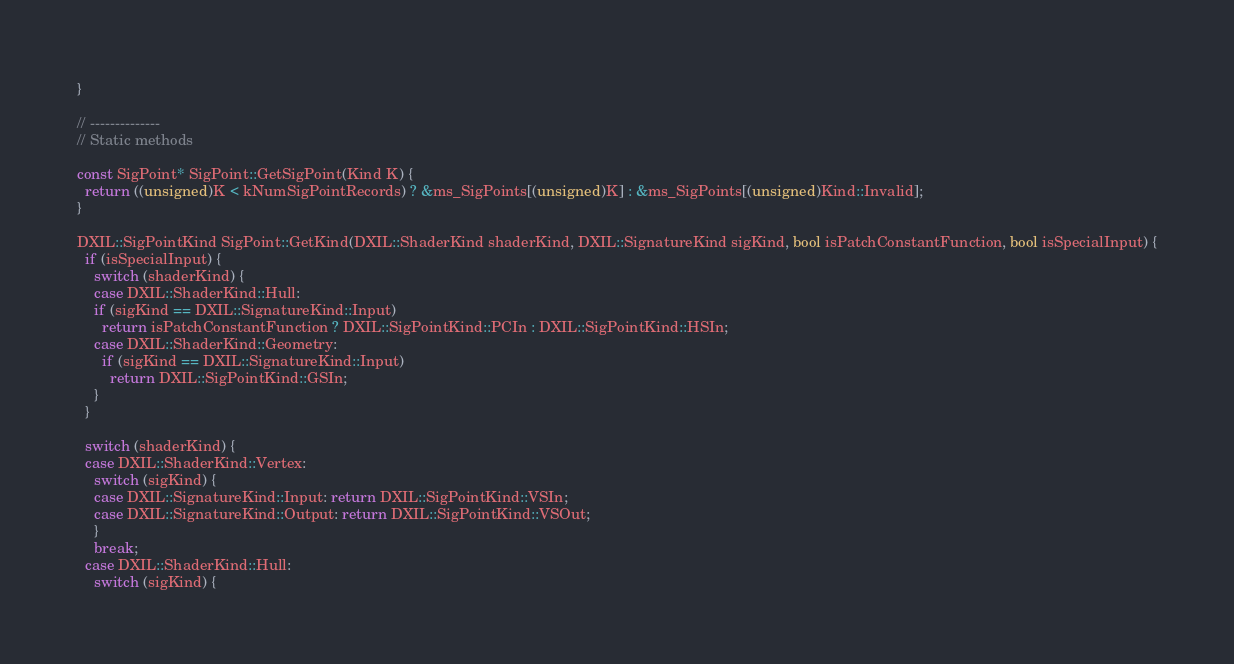<code> <loc_0><loc_0><loc_500><loc_500><_C++_>}

// --------------
// Static methods

const SigPoint* SigPoint::GetSigPoint(Kind K) {
  return ((unsigned)K < kNumSigPointRecords) ? &ms_SigPoints[(unsigned)K] : &ms_SigPoints[(unsigned)Kind::Invalid];
}

DXIL::SigPointKind SigPoint::GetKind(DXIL::ShaderKind shaderKind, DXIL::SignatureKind sigKind, bool isPatchConstantFunction, bool isSpecialInput) {
  if (isSpecialInput) {
    switch (shaderKind) {
    case DXIL::ShaderKind::Hull:
    if (sigKind == DXIL::SignatureKind::Input)
      return isPatchConstantFunction ? DXIL::SigPointKind::PCIn : DXIL::SigPointKind::HSIn;
    case DXIL::ShaderKind::Geometry:
      if (sigKind == DXIL::SignatureKind::Input)
        return DXIL::SigPointKind::GSIn;
    }
  }

  switch (shaderKind) {
  case DXIL::ShaderKind::Vertex:
    switch (sigKind) {
    case DXIL::SignatureKind::Input: return DXIL::SigPointKind::VSIn;
    case DXIL::SignatureKind::Output: return DXIL::SigPointKind::VSOut;
    }
    break;
  case DXIL::ShaderKind::Hull:
    switch (sigKind) {</code> 